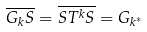<formula> <loc_0><loc_0><loc_500><loc_500>\overline { G _ { k } S } = \overline { S T ^ { k } S } = G _ { k ^ { * } }</formula> 